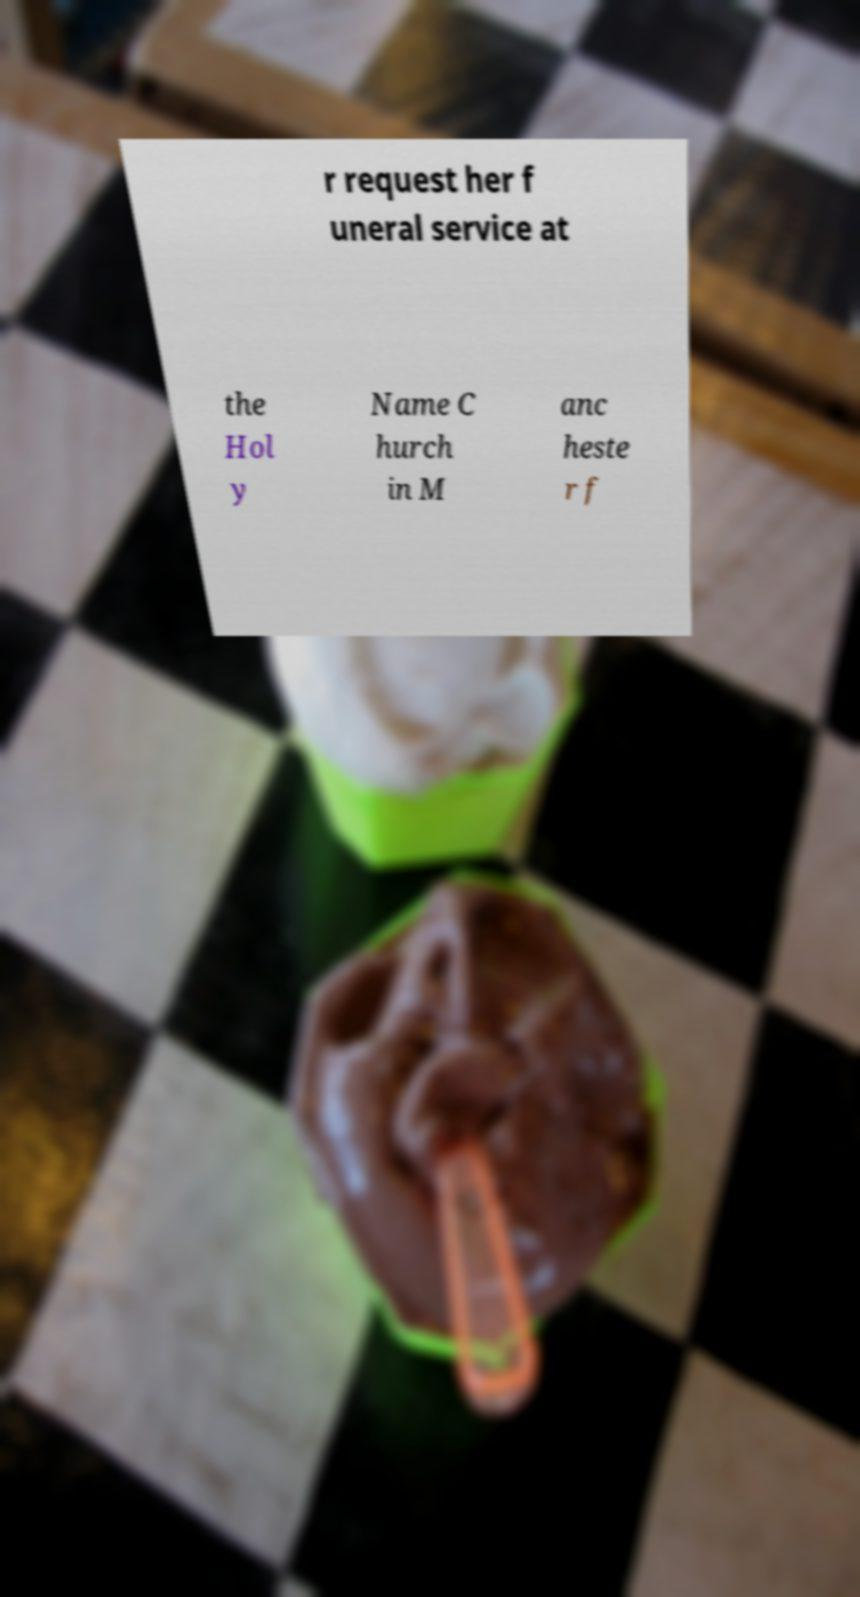Can you read and provide the text displayed in the image?This photo seems to have some interesting text. Can you extract and type it out for me? r request her f uneral service at the Hol y Name C hurch in M anc heste r f 